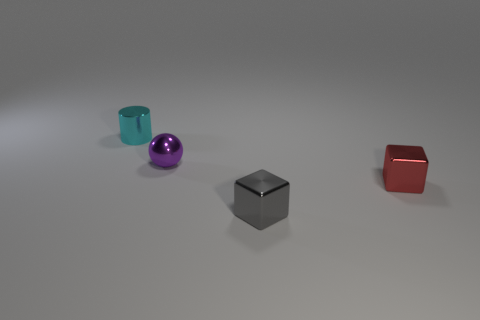There is a small sphere that is made of the same material as the tiny cylinder; what color is it?
Give a very brief answer. Purple. Do the purple thing and the tiny red object in front of the small purple object have the same material?
Provide a succinct answer. Yes. There is a shiny thing that is both behind the gray cube and in front of the small purple metallic object; what is its color?
Your response must be concise. Red. How many blocks are either purple metallic objects or yellow things?
Give a very brief answer. 0. There is a small red thing; is its shape the same as the metal thing in front of the red cube?
Offer a terse response. Yes. The red thing is what shape?
Ensure brevity in your answer.  Cube. Are there any objects in front of the small shiny object that is behind the small purple shiny thing?
Your response must be concise. Yes. There is a small metal object that is in front of the red thing; what number of small gray blocks are behind it?
Make the answer very short. 0. What is the material of the gray cube that is the same size as the purple shiny thing?
Ensure brevity in your answer.  Metal. There is a object in front of the small red metallic cube; is its shape the same as the small red metal object?
Your response must be concise. Yes. 